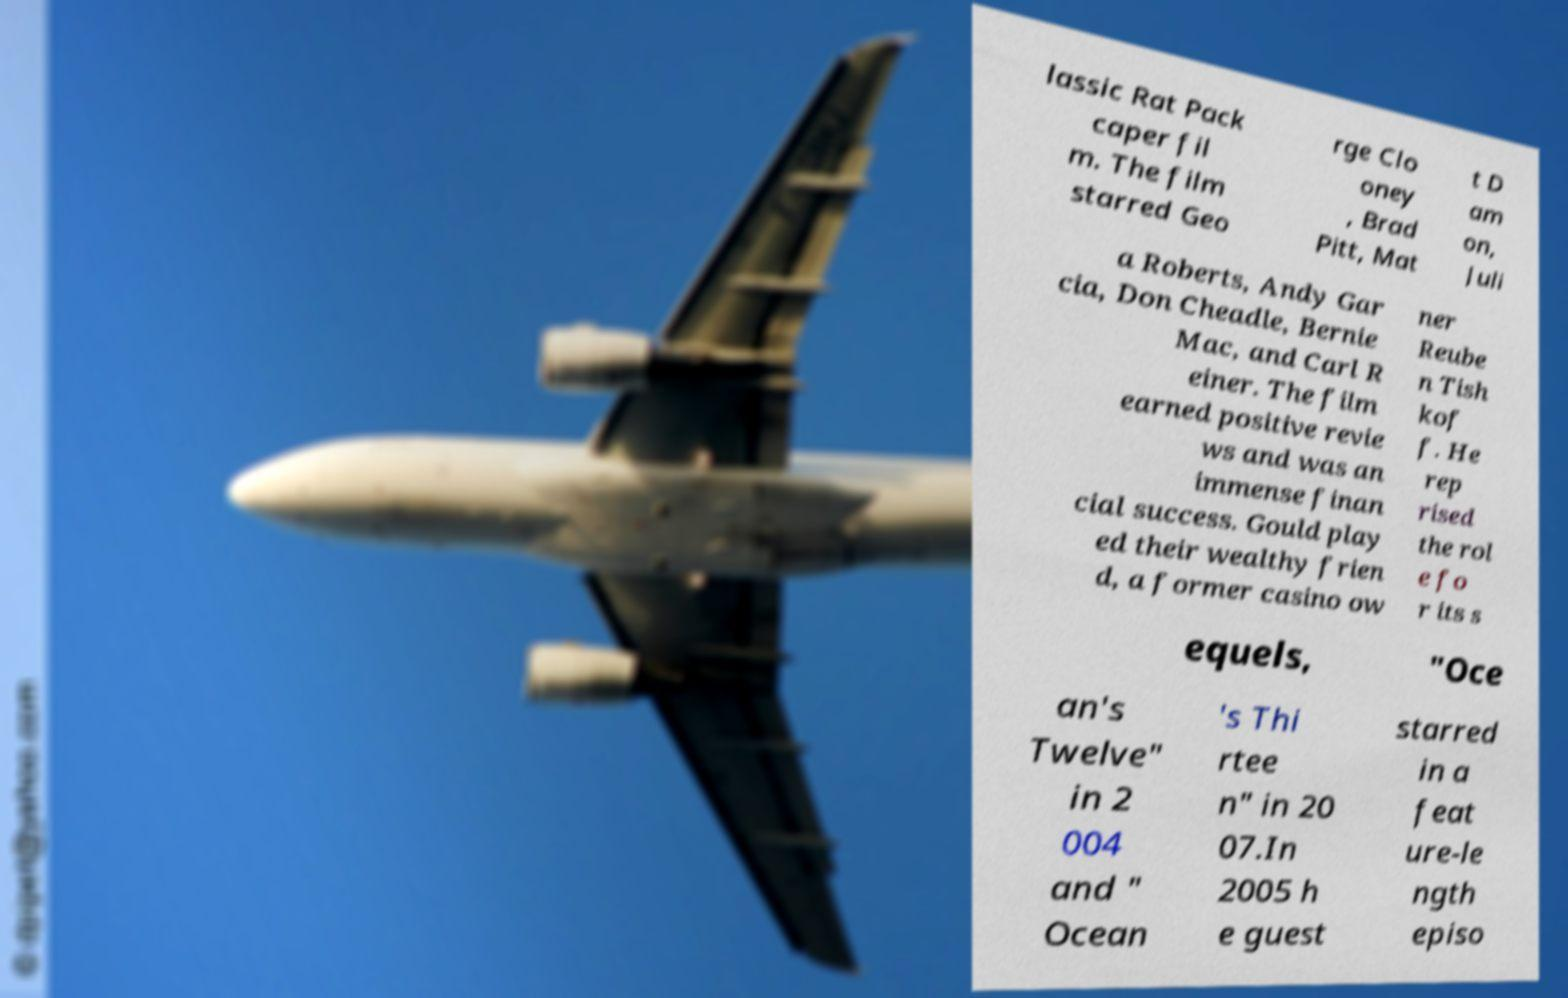I need the written content from this picture converted into text. Can you do that? lassic Rat Pack caper fil m. The film starred Geo rge Clo oney , Brad Pitt, Mat t D am on, Juli a Roberts, Andy Gar cia, Don Cheadle, Bernie Mac, and Carl R einer. The film earned positive revie ws and was an immense finan cial success. Gould play ed their wealthy frien d, a former casino ow ner Reube n Tish kof f. He rep rised the rol e fo r its s equels, "Oce an's Twelve" in 2 004 and " Ocean 's Thi rtee n" in 20 07.In 2005 h e guest starred in a feat ure-le ngth episo 